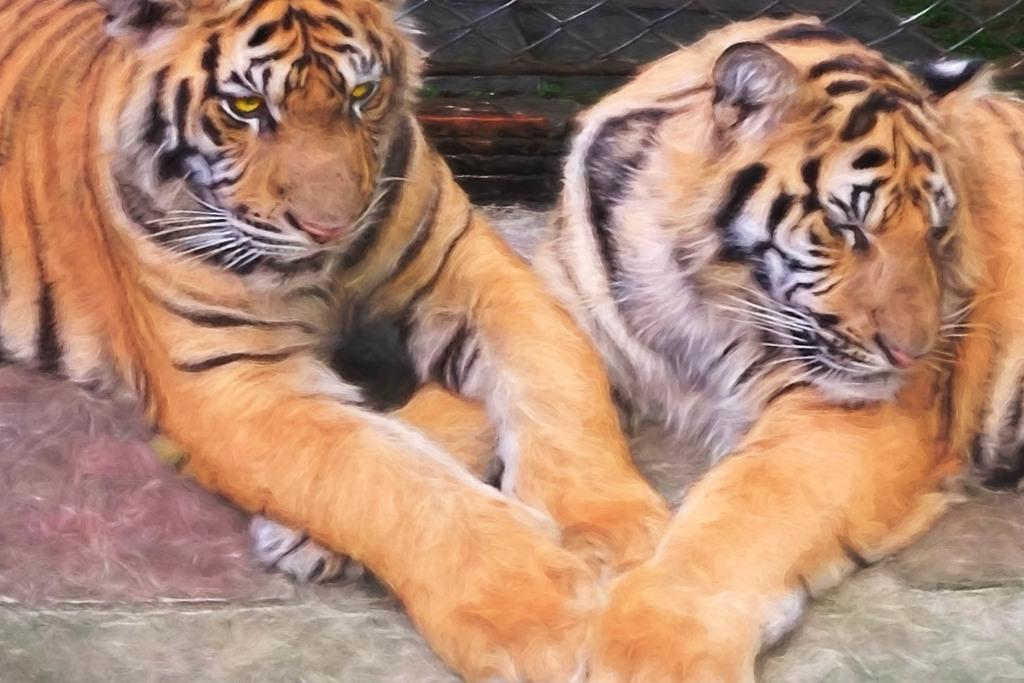How many tigers are present in the image? There are two tigers in the image. What can be seen in the background of the image? There is a black color wall or fence in the background of the image. Where might this image have been taken? The image might have been taken in a zoo. What type of chin is visible on the tigers in the image? Tigers do not have chins like humans; they have a snout and jawline. --- 